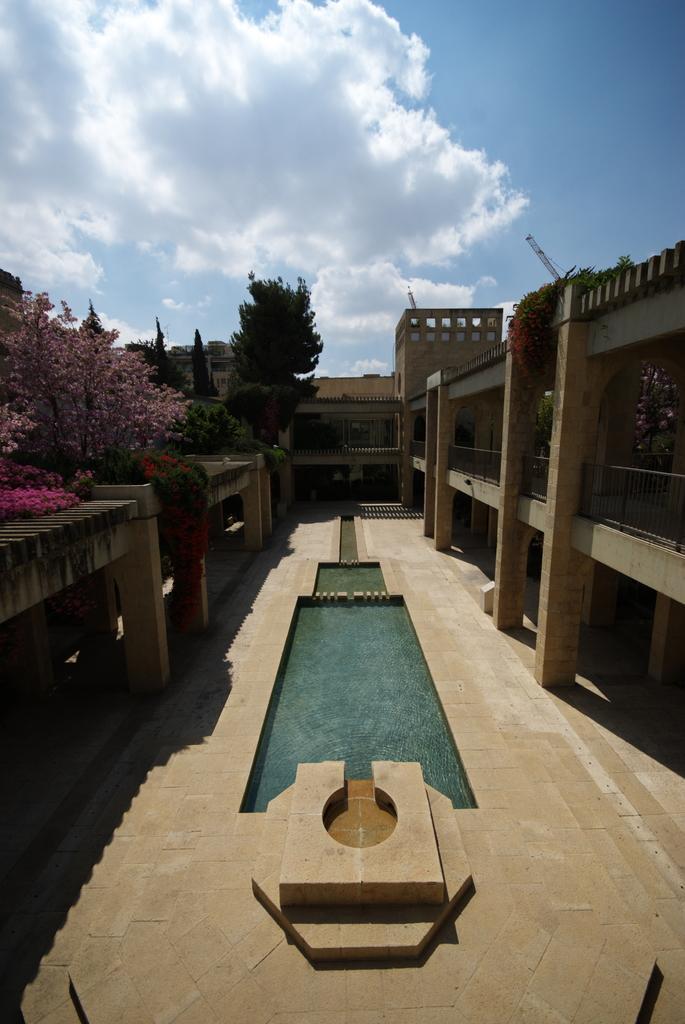Please provide a concise description of this image. In this image I can see the ground, the water, few trees which are green and pink in color and few buildings. In the background I can see the sky. 